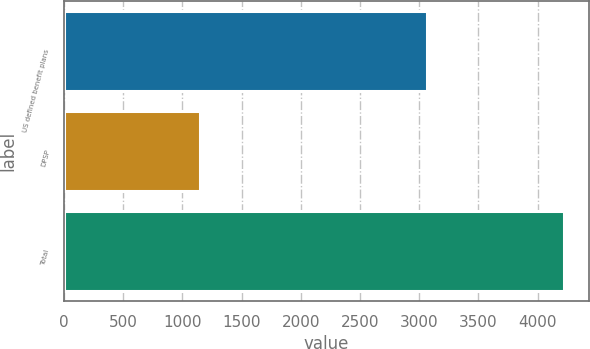<chart> <loc_0><loc_0><loc_500><loc_500><bar_chart><fcel>US defined benefit plans<fcel>DPSP<fcel>Total<nl><fcel>3070<fcel>1151<fcel>4221<nl></chart> 